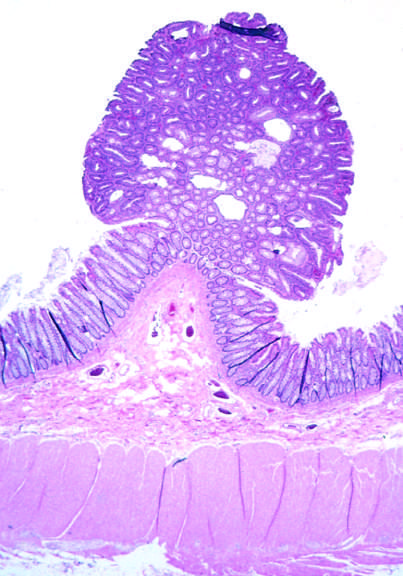what are small nests of epithelial cells and myxoid stroma forming?
Answer the question using a single word or phrase. Cartilage and bone 